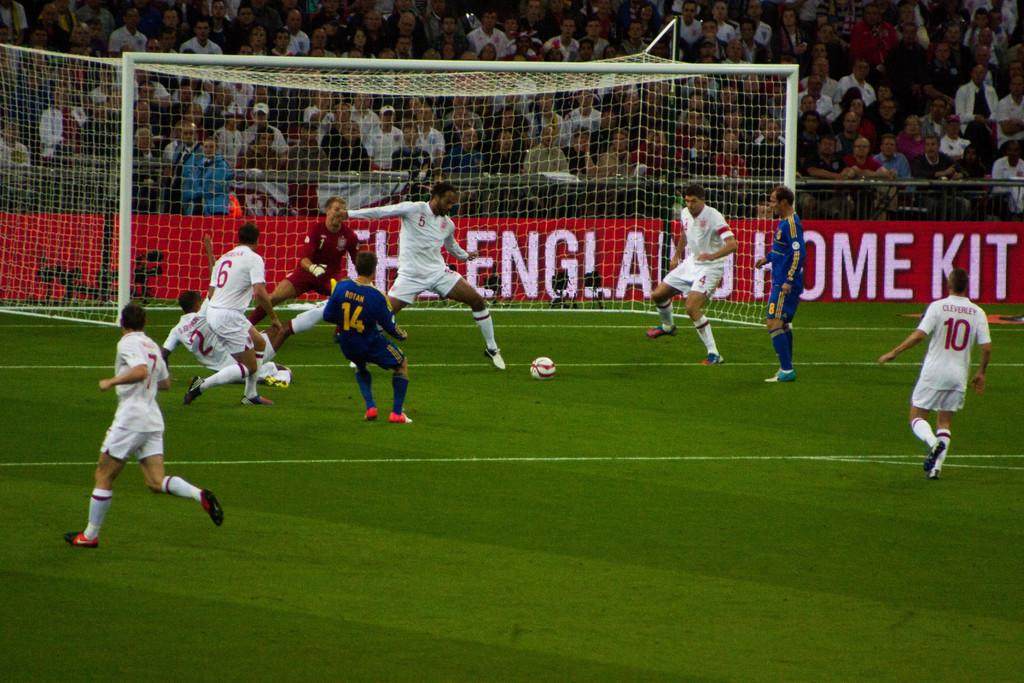What kind of kit is advertised?
Ensure brevity in your answer.  England home. What number is the player who has fallen down?
Provide a short and direct response. 2. 